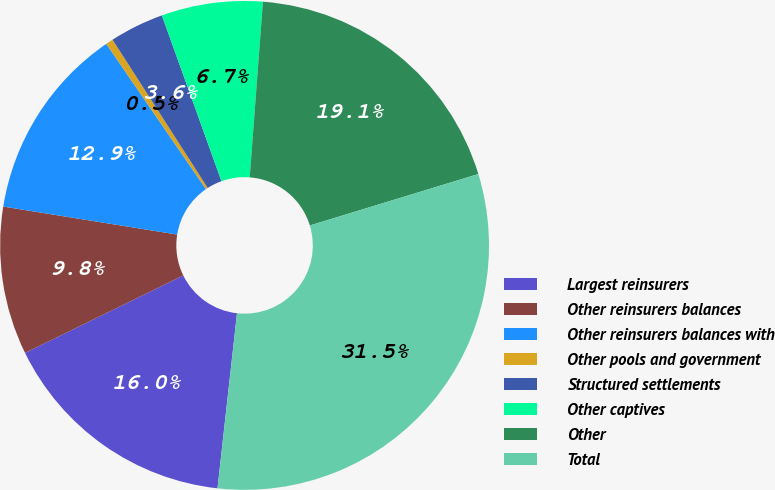Convert chart. <chart><loc_0><loc_0><loc_500><loc_500><pie_chart><fcel>Largest reinsurers<fcel>Other reinsurers balances<fcel>Other reinsurers balances with<fcel>Other pools and government<fcel>Structured settlements<fcel>Other captives<fcel>Other<fcel>Total<nl><fcel>15.99%<fcel>9.79%<fcel>12.89%<fcel>0.49%<fcel>3.59%<fcel>6.69%<fcel>19.09%<fcel>31.49%<nl></chart> 